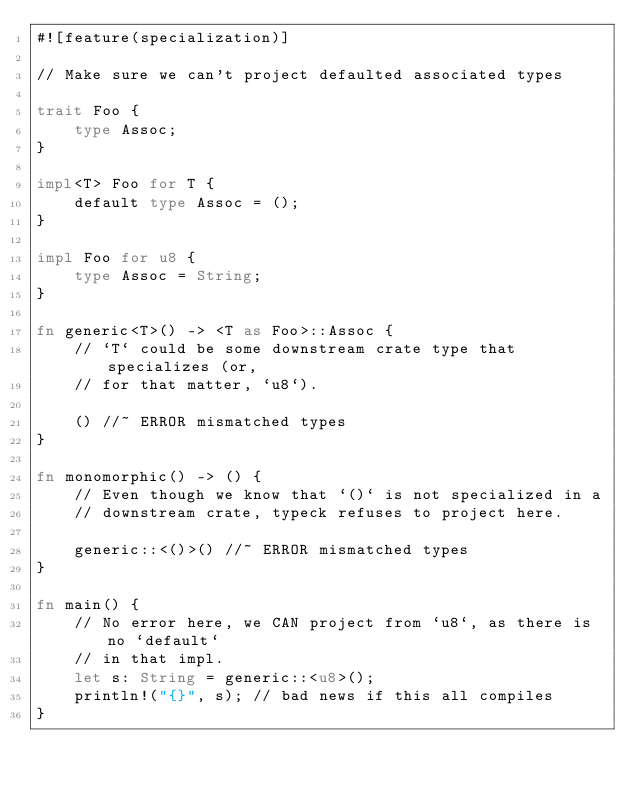<code> <loc_0><loc_0><loc_500><loc_500><_Rust_>#![feature(specialization)]

// Make sure we can't project defaulted associated types

trait Foo {
    type Assoc;
}

impl<T> Foo for T {
    default type Assoc = ();
}

impl Foo for u8 {
    type Assoc = String;
}

fn generic<T>() -> <T as Foo>::Assoc {
    // `T` could be some downstream crate type that specializes (or,
    // for that matter, `u8`).

    () //~ ERROR mismatched types
}

fn monomorphic() -> () {
    // Even though we know that `()` is not specialized in a
    // downstream crate, typeck refuses to project here.

    generic::<()>() //~ ERROR mismatched types
}

fn main() {
    // No error here, we CAN project from `u8`, as there is no `default`
    // in that impl.
    let s: String = generic::<u8>();
    println!("{}", s); // bad news if this all compiles
}
</code> 